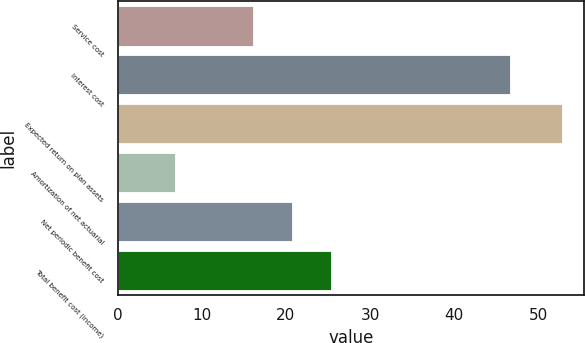<chart> <loc_0><loc_0><loc_500><loc_500><bar_chart><fcel>Service cost<fcel>Interest cost<fcel>Expected return on plan assets<fcel>Amortization of net actuarial<fcel>Net periodic benefit cost<fcel>Total benefit cost (income)<nl><fcel>16.1<fcel>46.6<fcel>52.8<fcel>6.8<fcel>20.7<fcel>25.3<nl></chart> 